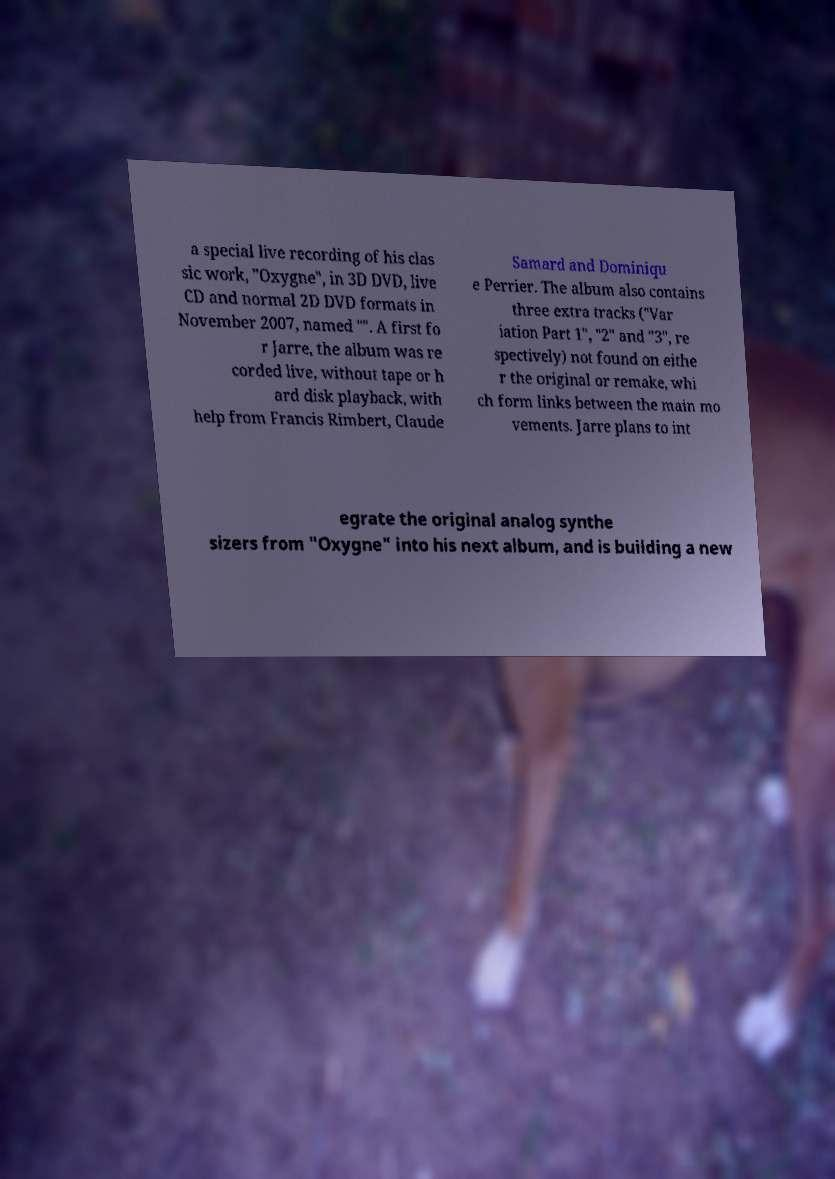What messages or text are displayed in this image? I need them in a readable, typed format. a special live recording of his clas sic work, "Oxygne", in 3D DVD, live CD and normal 2D DVD formats in November 2007, named "". A first fo r Jarre, the album was re corded live, without tape or h ard disk playback, with help from Francis Rimbert, Claude Samard and Dominiqu e Perrier. The album also contains three extra tracks ("Var iation Part 1", "2" and "3", re spectively) not found on eithe r the original or remake, whi ch form links between the main mo vements. Jarre plans to int egrate the original analog synthe sizers from "Oxygne" into his next album, and is building a new 